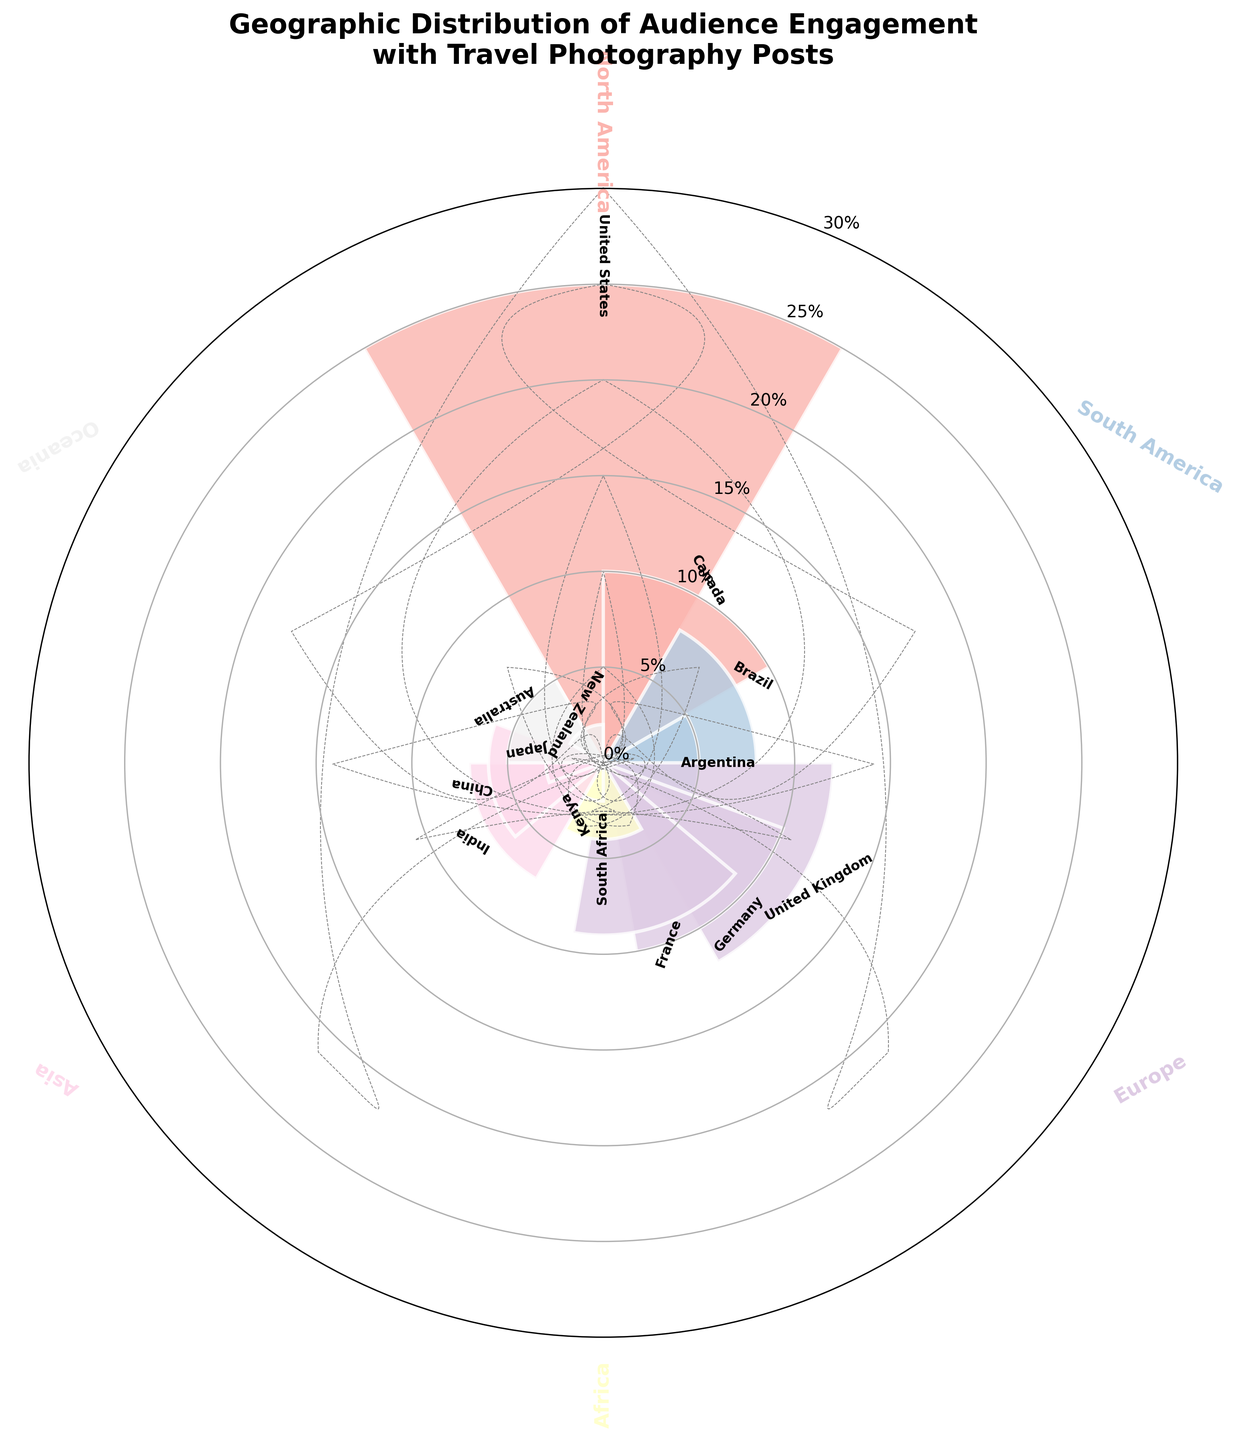What's the title of the figure? The title of the figure is prominently displayed at the top. Read the text to get the exact title.
Answer: Geographic Distribution of Audience Engagement with Travel Photography Posts Which continent has the highest engagement percentage for a single country? Look for the tallest bars in each segment. The tallest bar is in the North America segment for the United States.
Answer: North America What is the total engagement percentage for Europe? Identify the individual engagement percentages for countries in Europe and sum them up: United Kingdom (12%) + Germany (10%) + France (9%).
Answer: 31% Which country has the lowest engagement percentage, and what is that percentage? Look for the shortest bars and identify their labels. Kenya has the shortest bar with 2%.
Answer: Kenya, 2% How does the engagement in Canada compare to that in Australia? Compare the heights of the bars for Canada and Australia. Both have bars of different heights, with Canada at 10% and Australia at 5%.
Answer: Canada has higher engagement What is the average engagement percentage for the countries in Asia? Sum the engagement percentages for the Asian countries and divide by the number of countries: (India 7% + China 6% + Japan 3%) / 3 = 5.33%.
Answer: 5.33% Which continent has the most countries represented in this chart? Count the number of countries represented in each continent's segment and compare. Europe has the most with three countries.
Answer: Europe What is the engagement percentage of South America if you combine both countries? Add the engagement percentages of Brazil and Argentina: 8% + 5% = 13%.
Answer: 13% What is the engagement percentage difference between the United States and India? Subtract the engagement percentage of India from that of the United States: 25% - 7% = 18%.
Answer: 18% Is the engagement distribution more balanced in Europe or Asia? Compare the range of engagement percentages within European countries and Asian countries. Europe has more closely grouped percentages (12%, 10%, 9%) while Asia has a wider spread (7%, 6%, 3%).
Answer: Europe is more balanced 